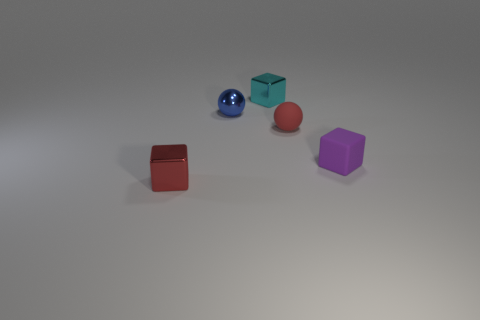Subtract all cyan shiny cubes. How many cubes are left? 2 Add 1 cyan shiny objects. How many objects exist? 6 Subtract all blue spheres. How many spheres are left? 1 Subtract 1 balls. How many balls are left? 1 Add 5 small matte blocks. How many small matte blocks are left? 6 Add 5 big green shiny balls. How many big green shiny balls exist? 5 Subtract 0 cyan cylinders. How many objects are left? 5 Subtract all blocks. How many objects are left? 2 Subtract all brown blocks. Subtract all red spheres. How many blocks are left? 3 Subtract all cyan cubes. How many gray balls are left? 0 